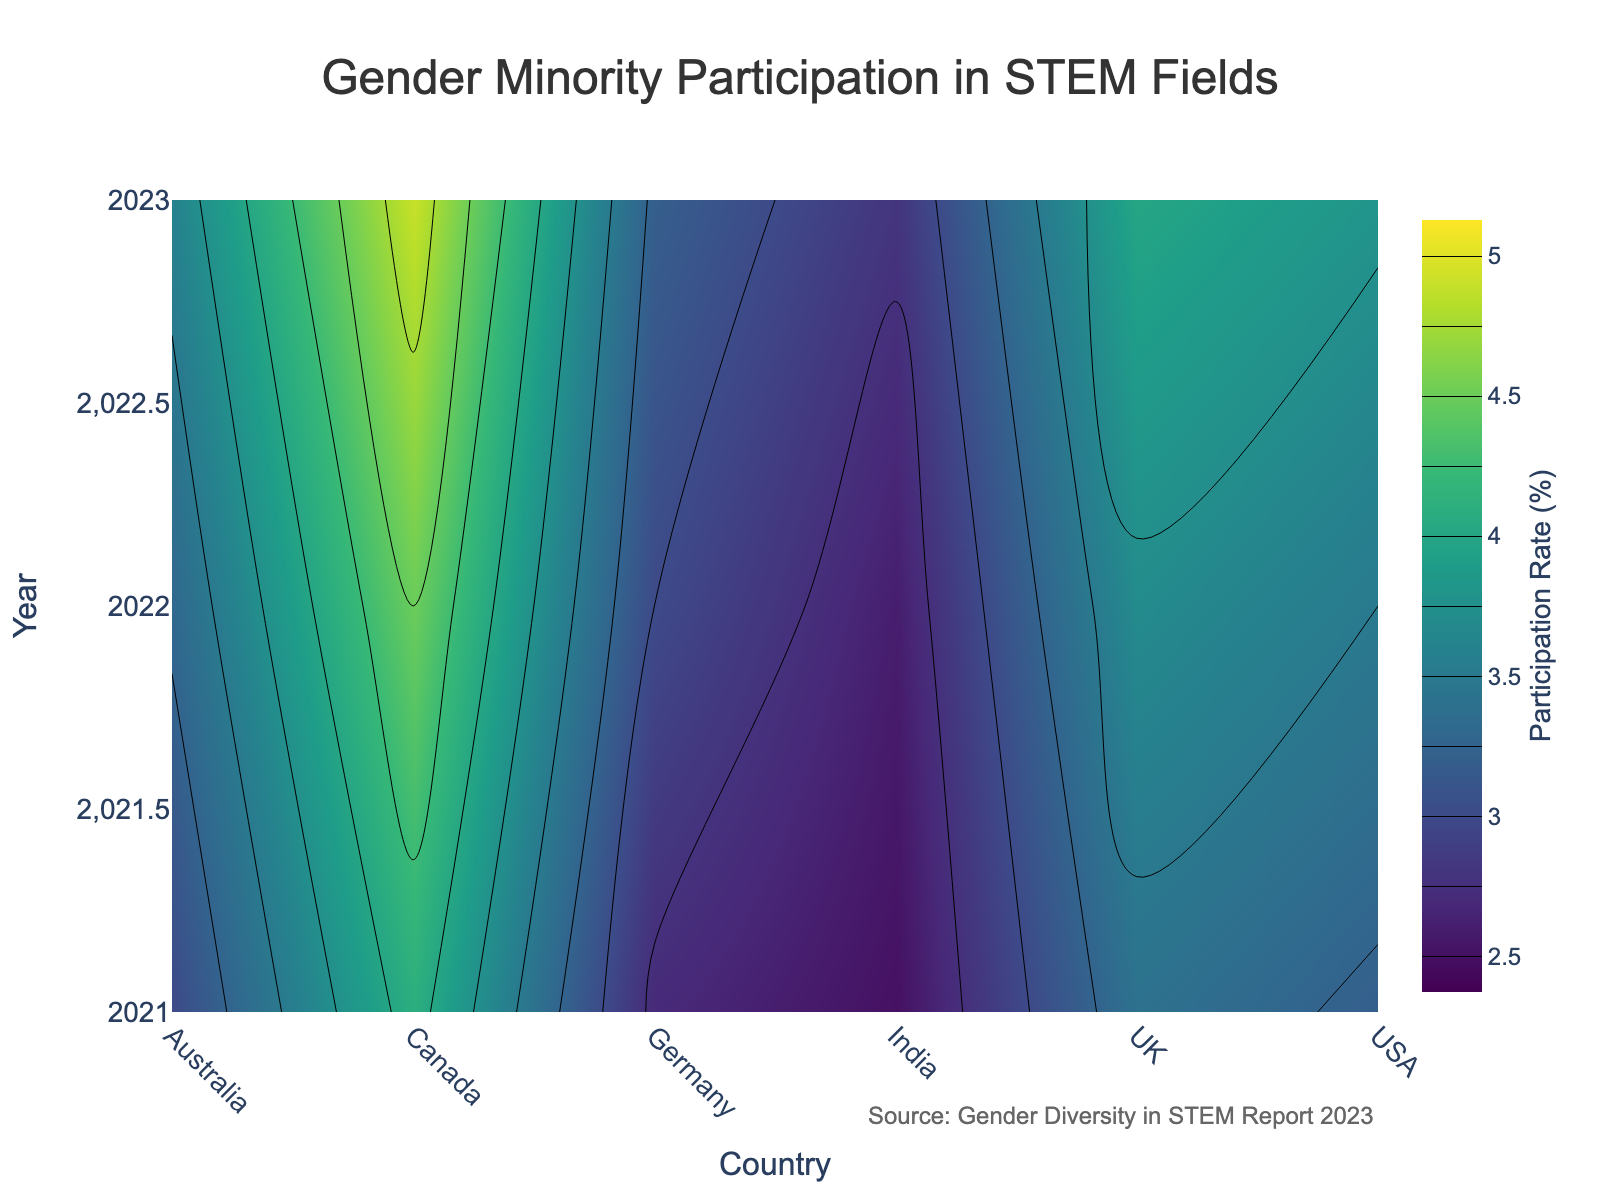What's the title of the contour plot? The title is typically prominently displayed at the top of the plot. On observing the figure, the title "Gender Minority Participation in STEM Fields" is shown.
Answer: Gender Minority Participation in STEM Fields Which country has the highest participation rate in 2023? The highest contour value for the year 2023 is observed. So, visually inspecting the plot at 2023 shows Canada having the highest participation rate.
Answer: Canada What is the participation rate for the USA in 2021? Identify the contour line intersecting the USA on the x-axis and 2021 on the y-axis, and follow it to the color bar. The value at this intersection is 3.2%.
Answer: 3.2% Compare the participation rates of gender minorities in STEM fields between Canada and Germany in 2022. Locate Canada and Germany on the x-axis, then observe their points on the y-axis at 2022. Canada's rate is higher than Germany’s.
Answer: Canada’s rate is higher What is the increase in participation rate for gender minorities in the UK from 2021 to 2023? Find the values for the UK in 2021 and 2023 first. The values are 3.4% and 4.0% respectively. The increase is 4.0% - 3.4% = 0.6%.
Answer: 0.6% In which year does India show the lowest participation rate in STEM fields? Look at the participation rate values for India across all years. The lowest value is observed in 2021 with 2.5%.
Answer: 2021 What's the average participation rate for Germany over the period from 2021 to 2023? Add the Germany rates for 2021 (2.7%), 2022 (3.0%), and 2023 (3.2%) then divide by 3. (2.7 + 3.0 + 3.2)/3 = 2.97%
Answer: 2.97% Among the listed countries, which shows the least variation in participation rates from 2021 to 2023? Calculate or visually estimate the range of participation rates for each country. India has the least variation (2.5% to 2.8%).
Answer: India How does the participation rate trend for Australia compare to the USA from 2021 to 2023? Note the trend lines' slope directions for both countries. Both have upward sloping trends, but Australia’s rates increase relatively more gradually compared to the USA.
Answer: Both increase, Australia more gradually 